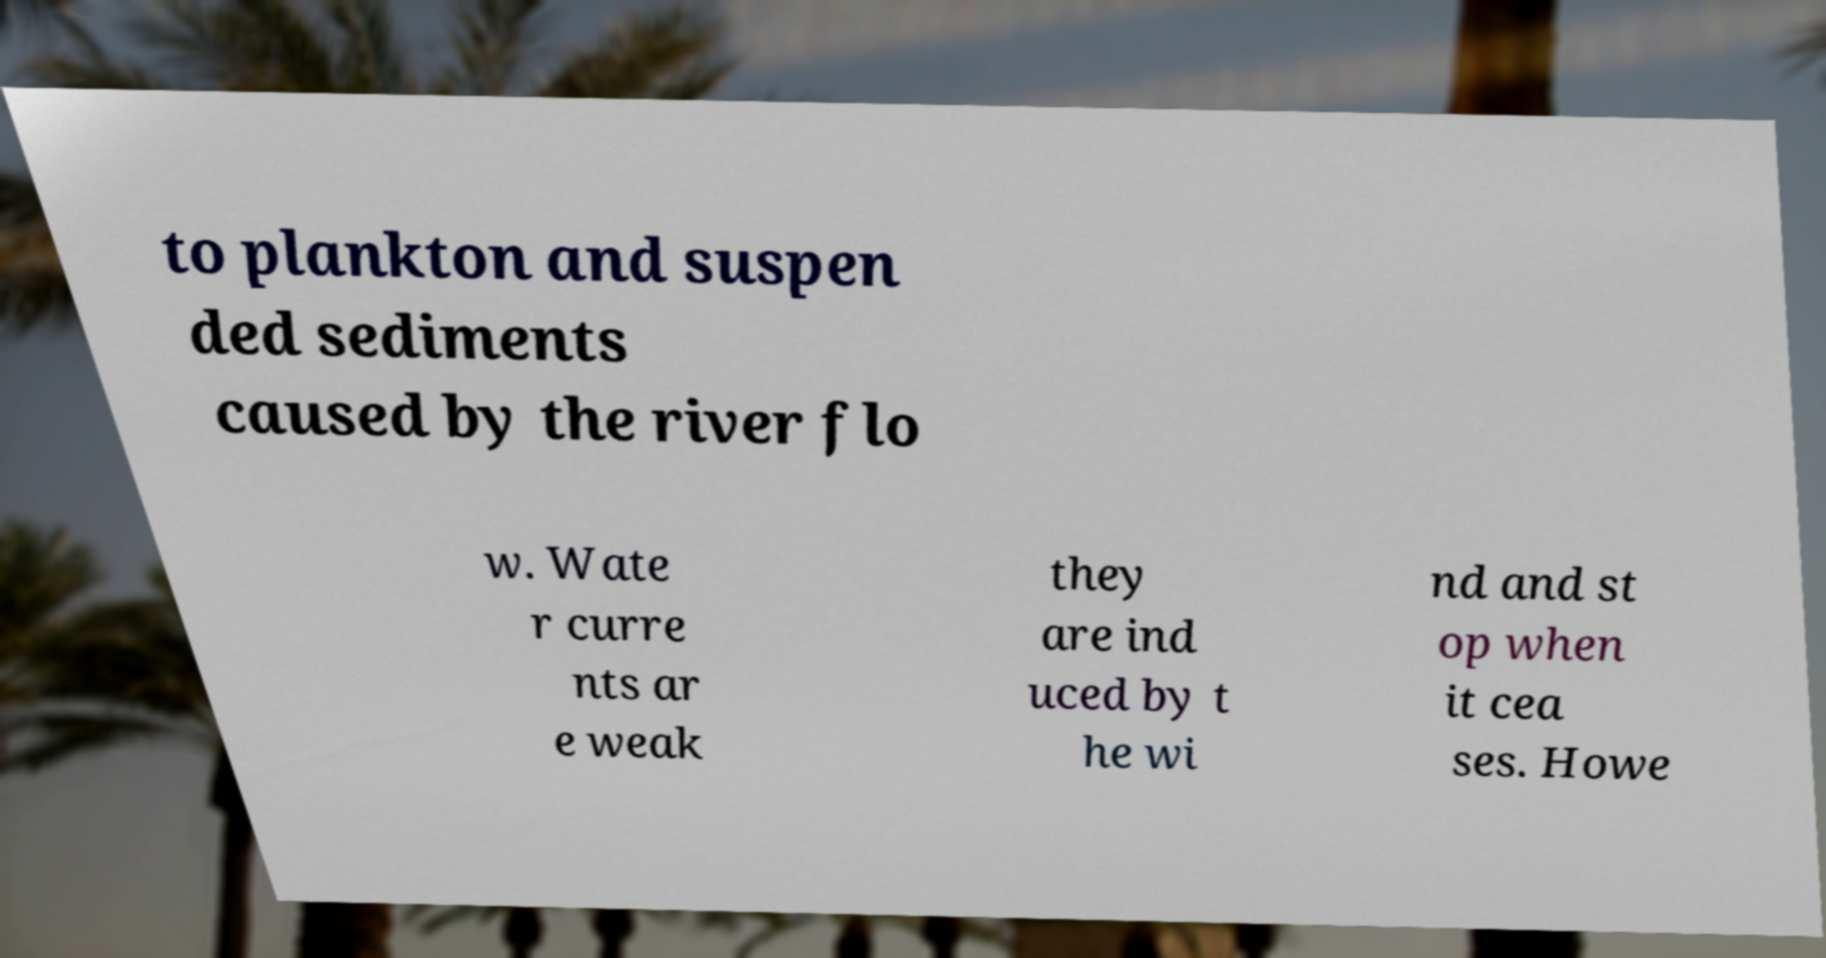There's text embedded in this image that I need extracted. Can you transcribe it verbatim? to plankton and suspen ded sediments caused by the river flo w. Wate r curre nts ar e weak they are ind uced by t he wi nd and st op when it cea ses. Howe 